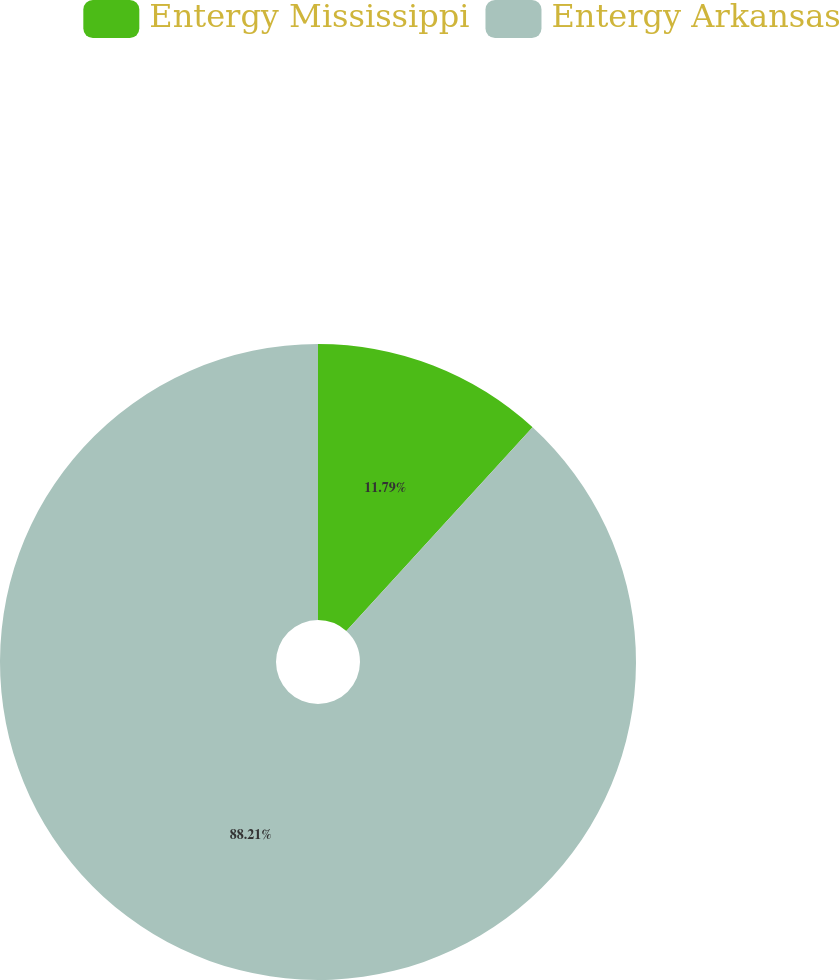<chart> <loc_0><loc_0><loc_500><loc_500><pie_chart><fcel>Entergy Mississippi<fcel>Entergy Arkansas<nl><fcel>11.79%<fcel>88.21%<nl></chart> 